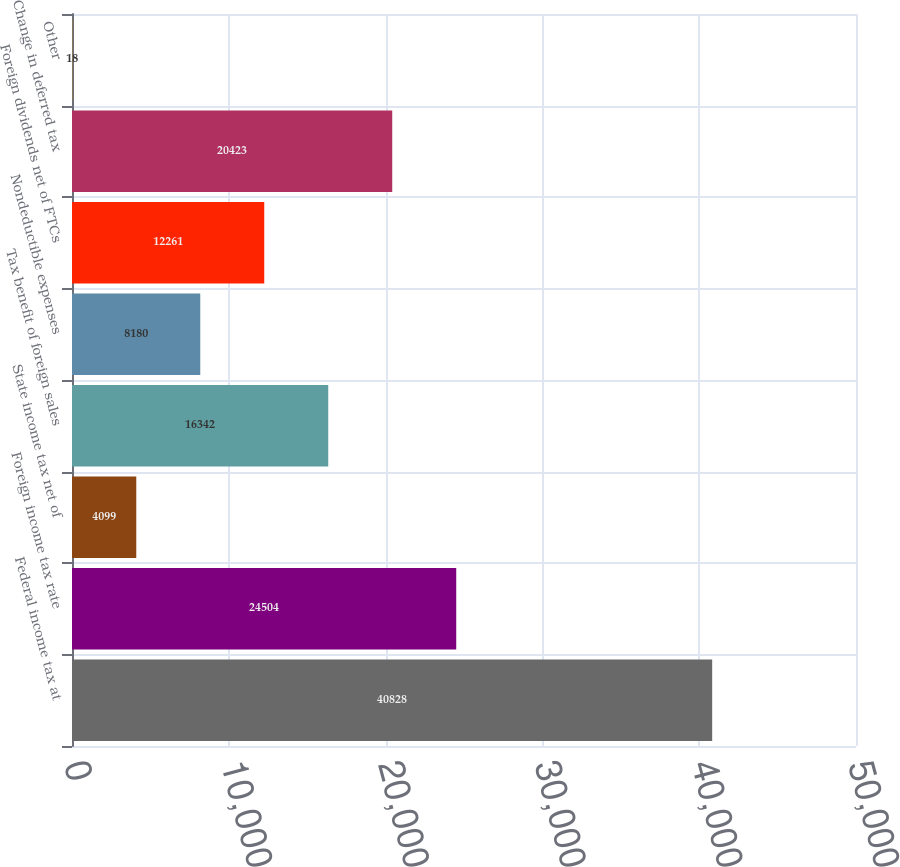Convert chart. <chart><loc_0><loc_0><loc_500><loc_500><bar_chart><fcel>Federal income tax at<fcel>Foreign income tax rate<fcel>State income tax net of<fcel>Tax benefit of foreign sales<fcel>Nondeductible expenses<fcel>Foreign dividends net of FTCs<fcel>Change in deferred tax<fcel>Other<nl><fcel>40828<fcel>24504<fcel>4099<fcel>16342<fcel>8180<fcel>12261<fcel>20423<fcel>18<nl></chart> 